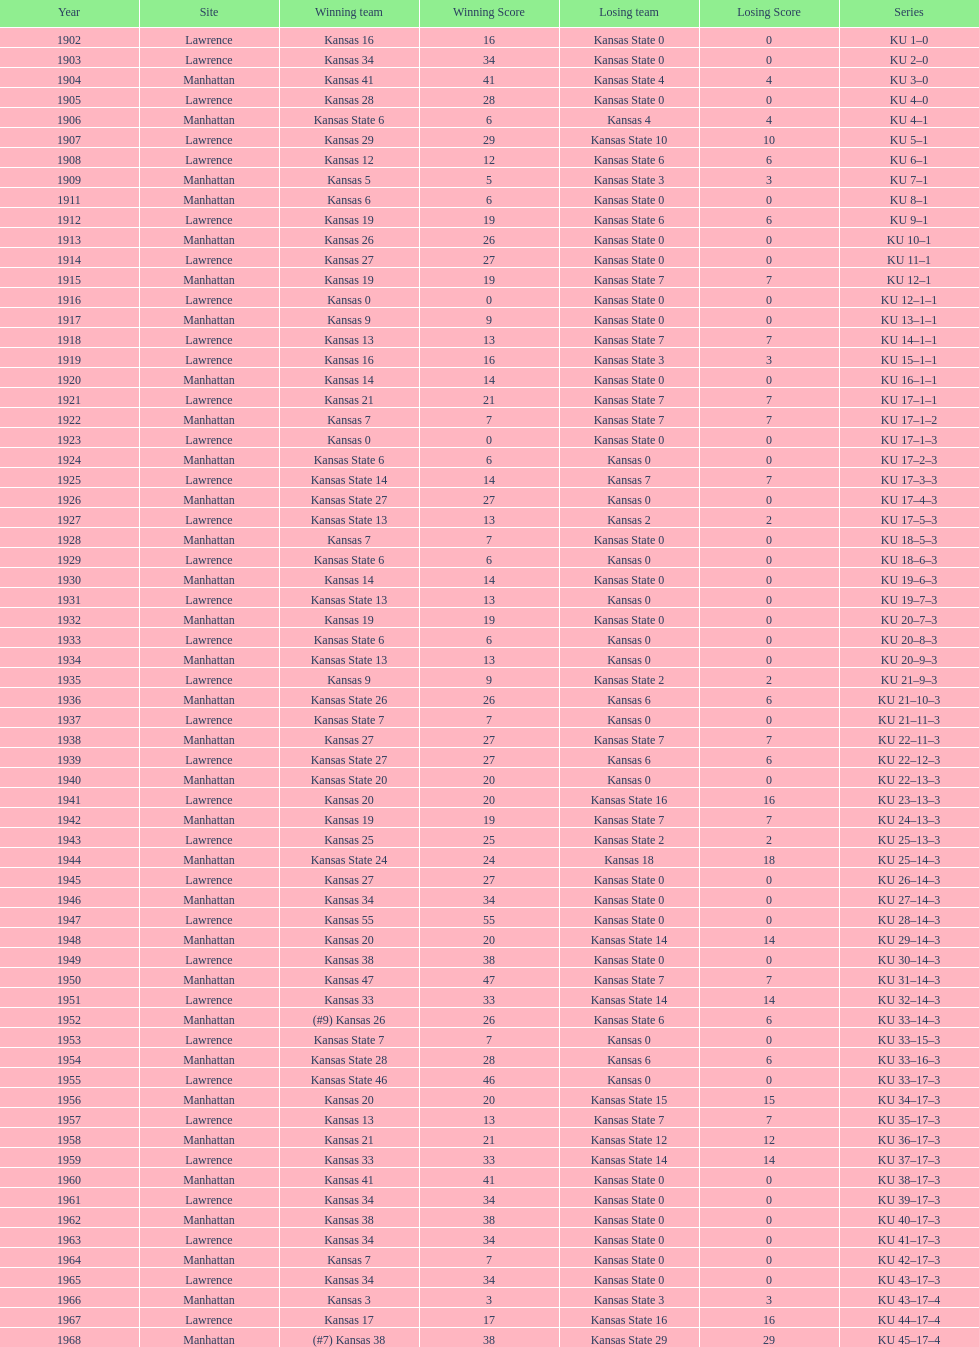What is the total number of games played? 66. 